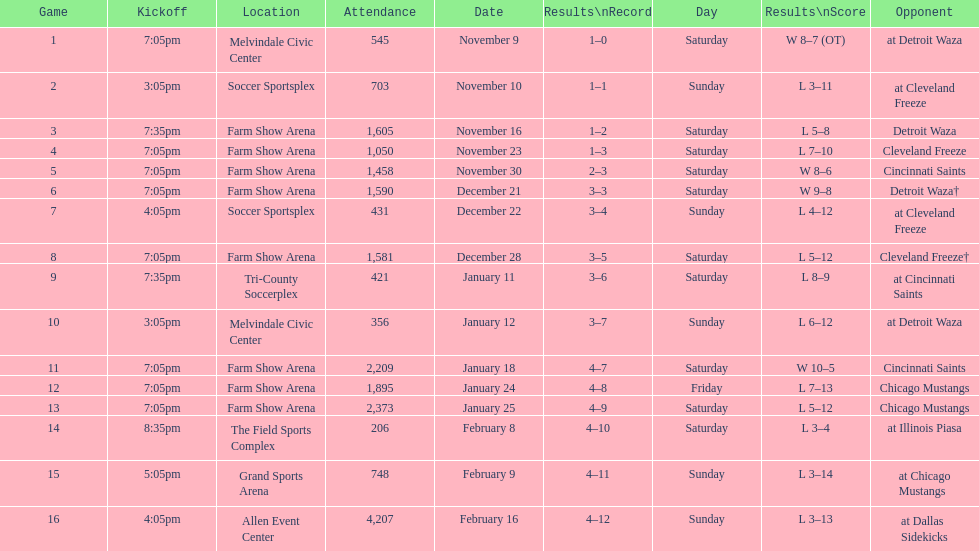How many games did the harrisburg heat lose to the cleveland freeze in total. 4. I'm looking to parse the entire table for insights. Could you assist me with that? {'header': ['Game', 'Kickoff', 'Location', 'Attendance', 'Date', 'Results\\nRecord', 'Day', 'Results\\nScore', 'Opponent'], 'rows': [['1', '7:05pm', 'Melvindale Civic Center', '545', 'November 9', '1–0', 'Saturday', 'W 8–7 (OT)', 'at Detroit Waza'], ['2', '3:05pm', 'Soccer Sportsplex', '703', 'November 10', '1–1', 'Sunday', 'L 3–11', 'at Cleveland Freeze'], ['3', '7:35pm', 'Farm Show Arena', '1,605', 'November 16', '1–2', 'Saturday', 'L 5–8', 'Detroit Waza'], ['4', '7:05pm', 'Farm Show Arena', '1,050', 'November 23', '1–3', 'Saturday', 'L 7–10', 'Cleveland Freeze'], ['5', '7:05pm', 'Farm Show Arena', '1,458', 'November 30', '2–3', 'Saturday', 'W 8–6', 'Cincinnati Saints'], ['6', '7:05pm', 'Farm Show Arena', '1,590', 'December 21', '3–3', 'Saturday', 'W 9–8', 'Detroit Waza†'], ['7', '4:05pm', 'Soccer Sportsplex', '431', 'December 22', '3–4', 'Sunday', 'L 4–12', 'at Cleveland Freeze'], ['8', '7:05pm', 'Farm Show Arena', '1,581', 'December 28', '3–5', 'Saturday', 'L 5–12', 'Cleveland Freeze†'], ['9', '7:35pm', 'Tri-County Soccerplex', '421', 'January 11', '3–6', 'Saturday', 'L 8–9', 'at Cincinnati Saints'], ['10', '3:05pm', 'Melvindale Civic Center', '356', 'January 12', '3–7', 'Sunday', 'L 6–12', 'at Detroit Waza'], ['11', '7:05pm', 'Farm Show Arena', '2,209', 'January 18', '4–7', 'Saturday', 'W 10–5', 'Cincinnati Saints'], ['12', '7:05pm', 'Farm Show Arena', '1,895', 'January 24', '4–8', 'Friday', 'L 7–13', 'Chicago Mustangs'], ['13', '7:05pm', 'Farm Show Arena', '2,373', 'January 25', '4–9', 'Saturday', 'L 5–12', 'Chicago Mustangs'], ['14', '8:35pm', 'The Field Sports Complex', '206', 'February 8', '4–10', 'Saturday', 'L 3–4', 'at Illinois Piasa'], ['15', '5:05pm', 'Grand Sports Arena', '748', 'February 9', '4–11', 'Sunday', 'L 3–14', 'at Chicago Mustangs'], ['16', '4:05pm', 'Allen Event Center', '4,207', 'February 16', '4–12', 'Sunday', 'L 3–13', 'at Dallas Sidekicks']]} 